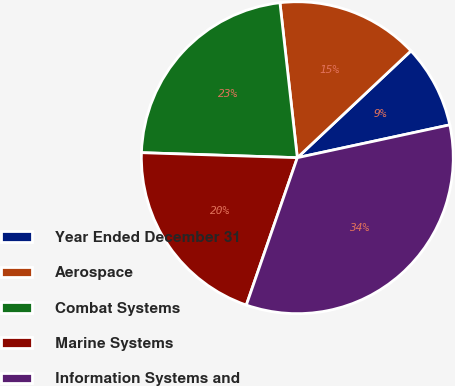Convert chart to OTSL. <chart><loc_0><loc_0><loc_500><loc_500><pie_chart><fcel>Year Ended December 31<fcel>Aerospace<fcel>Combat Systems<fcel>Marine Systems<fcel>Information Systems and<nl><fcel>8.63%<fcel>14.77%<fcel>22.71%<fcel>20.21%<fcel>33.68%<nl></chart> 